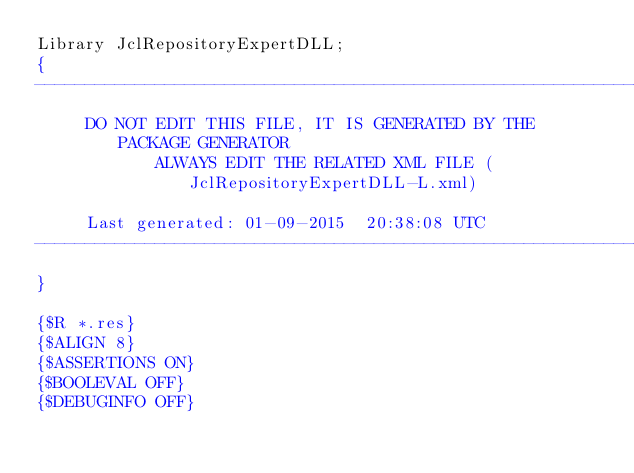<code> <loc_0><loc_0><loc_500><loc_500><_Pascal_>Library JclRepositoryExpertDLL;
{
-----------------------------------------------------------------------------
     DO NOT EDIT THIS FILE, IT IS GENERATED BY THE PACKAGE GENERATOR
            ALWAYS EDIT THE RELATED XML FILE (JclRepositoryExpertDLL-L.xml)

     Last generated: 01-09-2015  20:38:08 UTC
-----------------------------------------------------------------------------
}

{$R *.res}
{$ALIGN 8}
{$ASSERTIONS ON}
{$BOOLEVAL OFF}
{$DEBUGINFO OFF}</code> 